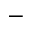Convert formula to latex. <formula><loc_0><loc_0><loc_500><loc_500>^ { - }</formula> 